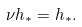Convert formula to latex. <formula><loc_0><loc_0><loc_500><loc_500>\nu { h } _ { * } = { h } _ { * } .</formula> 